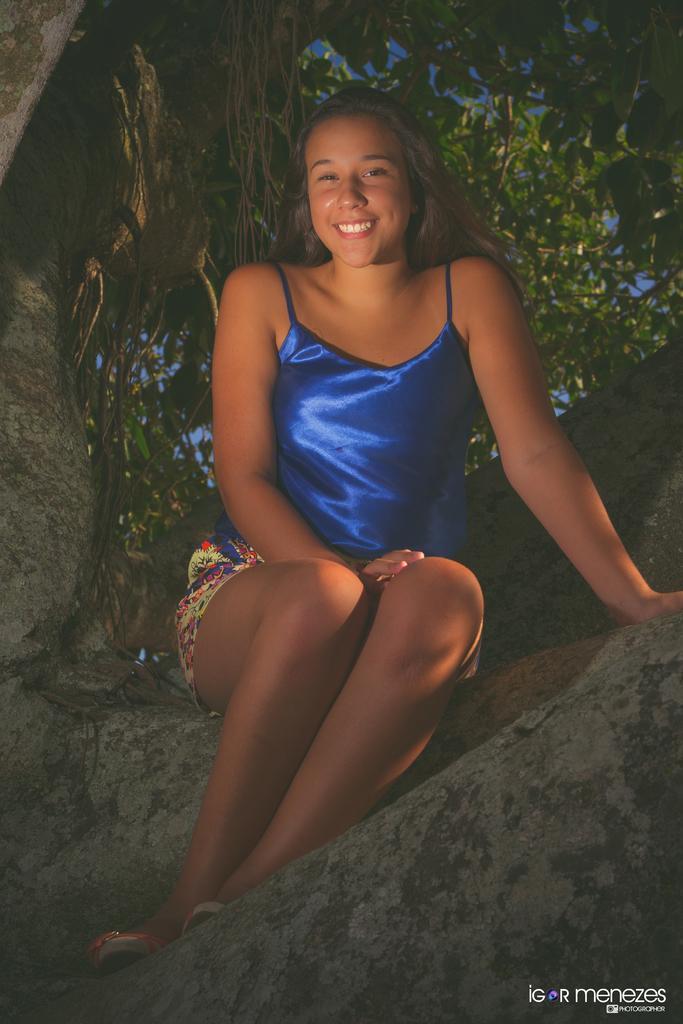Describe this image in one or two sentences. In the picture we can see a woman sitting on the rock slope and she is with blue top and she is smiling and behind her we can see some part of the tree. 